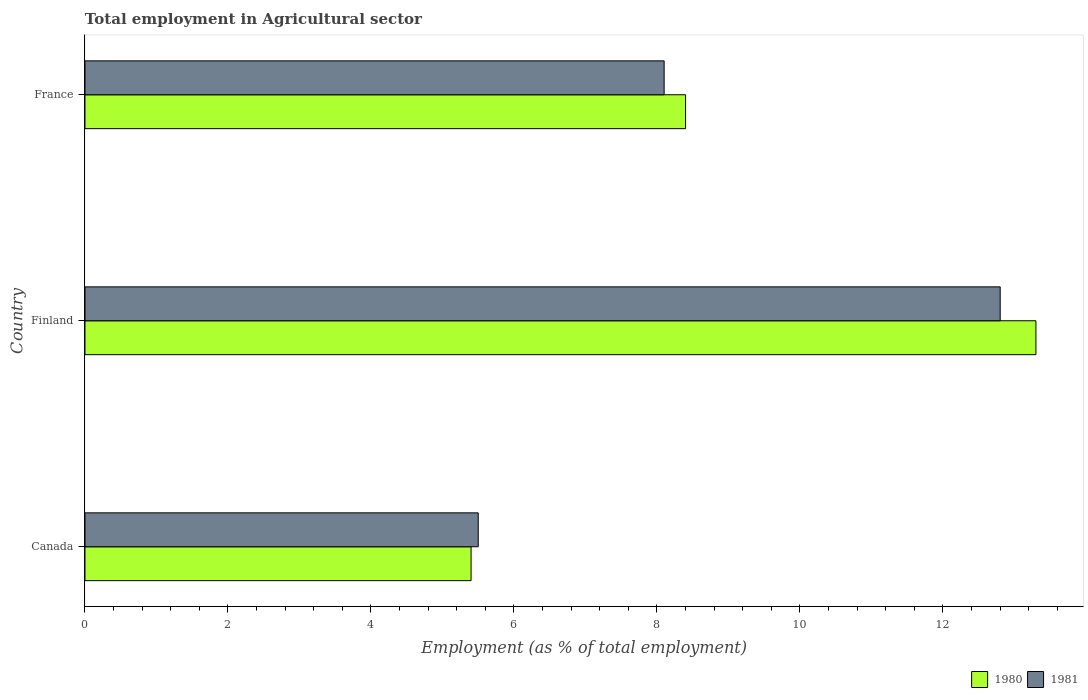How many groups of bars are there?
Offer a terse response. 3. Are the number of bars per tick equal to the number of legend labels?
Your answer should be very brief. Yes. Are the number of bars on each tick of the Y-axis equal?
Offer a very short reply. Yes. What is the label of the 2nd group of bars from the top?
Offer a terse response. Finland. In how many cases, is the number of bars for a given country not equal to the number of legend labels?
Provide a succinct answer. 0. What is the employment in agricultural sector in 1980 in France?
Your answer should be very brief. 8.4. Across all countries, what is the maximum employment in agricultural sector in 1981?
Give a very brief answer. 12.8. In which country was the employment in agricultural sector in 1980 maximum?
Offer a terse response. Finland. In which country was the employment in agricultural sector in 1981 minimum?
Give a very brief answer. Canada. What is the total employment in agricultural sector in 1981 in the graph?
Your answer should be compact. 26.4. What is the difference between the employment in agricultural sector in 1981 in Canada and that in Finland?
Your answer should be very brief. -7.3. What is the difference between the employment in agricultural sector in 1981 in Canada and the employment in agricultural sector in 1980 in France?
Ensure brevity in your answer.  -2.9. What is the average employment in agricultural sector in 1980 per country?
Ensure brevity in your answer.  9.03. What is the difference between the employment in agricultural sector in 1981 and employment in agricultural sector in 1980 in France?
Make the answer very short. -0.3. What is the ratio of the employment in agricultural sector in 1980 in Canada to that in Finland?
Provide a succinct answer. 0.41. Is the employment in agricultural sector in 1980 in Canada less than that in Finland?
Give a very brief answer. Yes. What is the difference between the highest and the second highest employment in agricultural sector in 1980?
Your answer should be very brief. 4.9. What is the difference between the highest and the lowest employment in agricultural sector in 1980?
Keep it short and to the point. 7.9. In how many countries, is the employment in agricultural sector in 1980 greater than the average employment in agricultural sector in 1980 taken over all countries?
Your answer should be compact. 1. What does the 2nd bar from the top in France represents?
Offer a very short reply. 1980. What does the 1st bar from the bottom in Finland represents?
Ensure brevity in your answer.  1980. Are all the bars in the graph horizontal?
Make the answer very short. Yes. How many countries are there in the graph?
Your answer should be compact. 3. Are the values on the major ticks of X-axis written in scientific E-notation?
Your response must be concise. No. Does the graph contain any zero values?
Your answer should be very brief. No. Does the graph contain grids?
Offer a terse response. No. Where does the legend appear in the graph?
Offer a very short reply. Bottom right. How many legend labels are there?
Make the answer very short. 2. How are the legend labels stacked?
Offer a terse response. Horizontal. What is the title of the graph?
Keep it short and to the point. Total employment in Agricultural sector. What is the label or title of the X-axis?
Give a very brief answer. Employment (as % of total employment). What is the Employment (as % of total employment) in 1980 in Canada?
Your response must be concise. 5.4. What is the Employment (as % of total employment) in 1981 in Canada?
Keep it short and to the point. 5.5. What is the Employment (as % of total employment) in 1980 in Finland?
Provide a short and direct response. 13.3. What is the Employment (as % of total employment) in 1981 in Finland?
Your response must be concise. 12.8. What is the Employment (as % of total employment) of 1980 in France?
Your response must be concise. 8.4. What is the Employment (as % of total employment) of 1981 in France?
Your answer should be compact. 8.1. Across all countries, what is the maximum Employment (as % of total employment) in 1980?
Provide a short and direct response. 13.3. Across all countries, what is the maximum Employment (as % of total employment) of 1981?
Offer a terse response. 12.8. Across all countries, what is the minimum Employment (as % of total employment) of 1980?
Offer a terse response. 5.4. Across all countries, what is the minimum Employment (as % of total employment) in 1981?
Ensure brevity in your answer.  5.5. What is the total Employment (as % of total employment) of 1980 in the graph?
Ensure brevity in your answer.  27.1. What is the total Employment (as % of total employment) in 1981 in the graph?
Offer a very short reply. 26.4. What is the difference between the Employment (as % of total employment) in 1980 in Canada and that in Finland?
Ensure brevity in your answer.  -7.9. What is the difference between the Employment (as % of total employment) in 1980 in Canada and that in France?
Make the answer very short. -3. What is the difference between the Employment (as % of total employment) of 1980 in Finland and that in France?
Make the answer very short. 4.9. What is the difference between the Employment (as % of total employment) of 1981 in Finland and that in France?
Provide a succinct answer. 4.7. What is the difference between the Employment (as % of total employment) of 1980 in Canada and the Employment (as % of total employment) of 1981 in Finland?
Provide a succinct answer. -7.4. What is the difference between the Employment (as % of total employment) of 1980 in Finland and the Employment (as % of total employment) of 1981 in France?
Make the answer very short. 5.2. What is the average Employment (as % of total employment) in 1980 per country?
Offer a terse response. 9.03. What is the average Employment (as % of total employment) of 1981 per country?
Your response must be concise. 8.8. What is the difference between the Employment (as % of total employment) of 1980 and Employment (as % of total employment) of 1981 in France?
Your response must be concise. 0.3. What is the ratio of the Employment (as % of total employment) in 1980 in Canada to that in Finland?
Ensure brevity in your answer.  0.41. What is the ratio of the Employment (as % of total employment) of 1981 in Canada to that in Finland?
Ensure brevity in your answer.  0.43. What is the ratio of the Employment (as % of total employment) of 1980 in Canada to that in France?
Provide a short and direct response. 0.64. What is the ratio of the Employment (as % of total employment) in 1981 in Canada to that in France?
Offer a terse response. 0.68. What is the ratio of the Employment (as % of total employment) in 1980 in Finland to that in France?
Provide a short and direct response. 1.58. What is the ratio of the Employment (as % of total employment) of 1981 in Finland to that in France?
Provide a short and direct response. 1.58. What is the difference between the highest and the second highest Employment (as % of total employment) of 1980?
Make the answer very short. 4.9. What is the difference between the highest and the second highest Employment (as % of total employment) of 1981?
Provide a short and direct response. 4.7. 